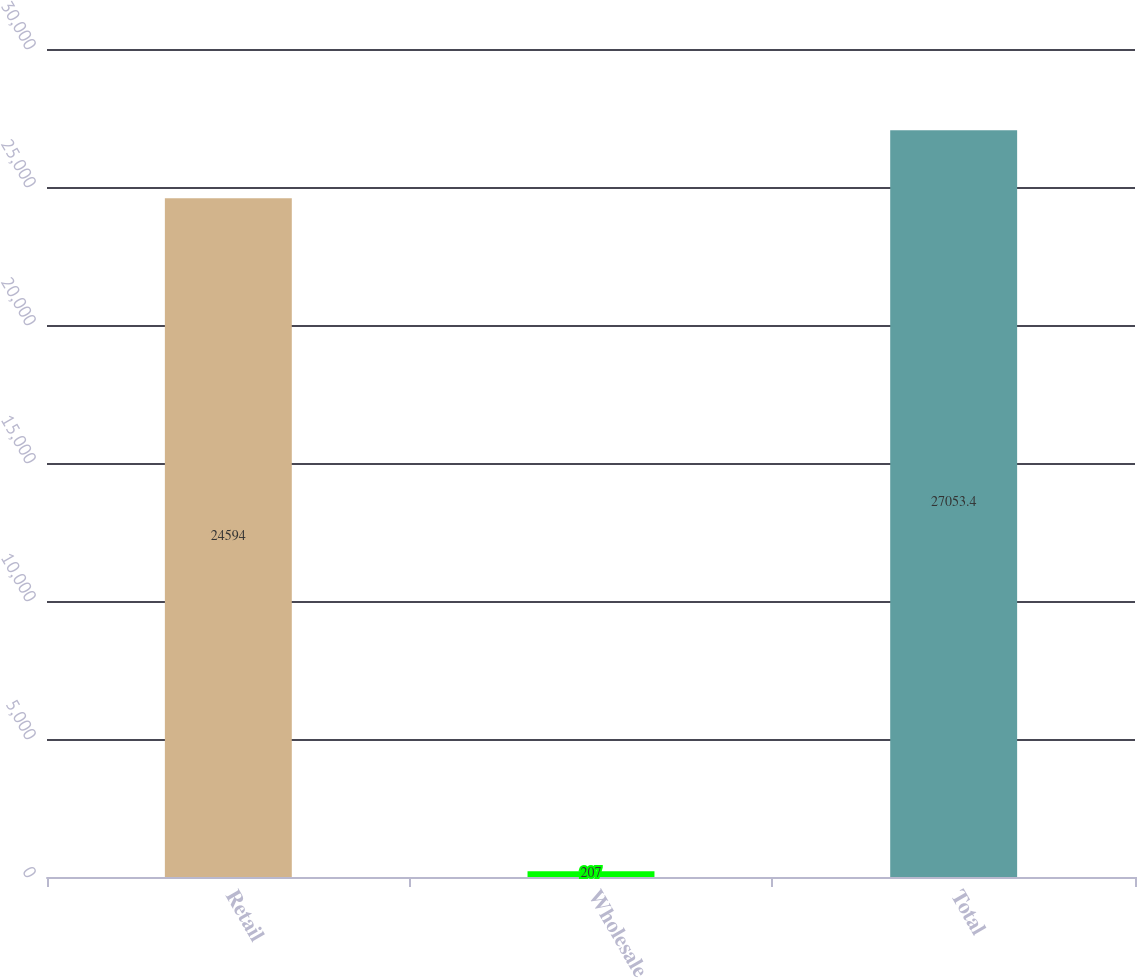<chart> <loc_0><loc_0><loc_500><loc_500><bar_chart><fcel>Retail<fcel>Wholesale<fcel>Total<nl><fcel>24594<fcel>207<fcel>27053.4<nl></chart> 